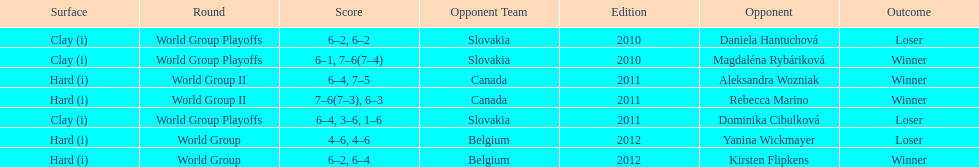In the match with dominika cibulkova, what was the total number of games played? 3. 